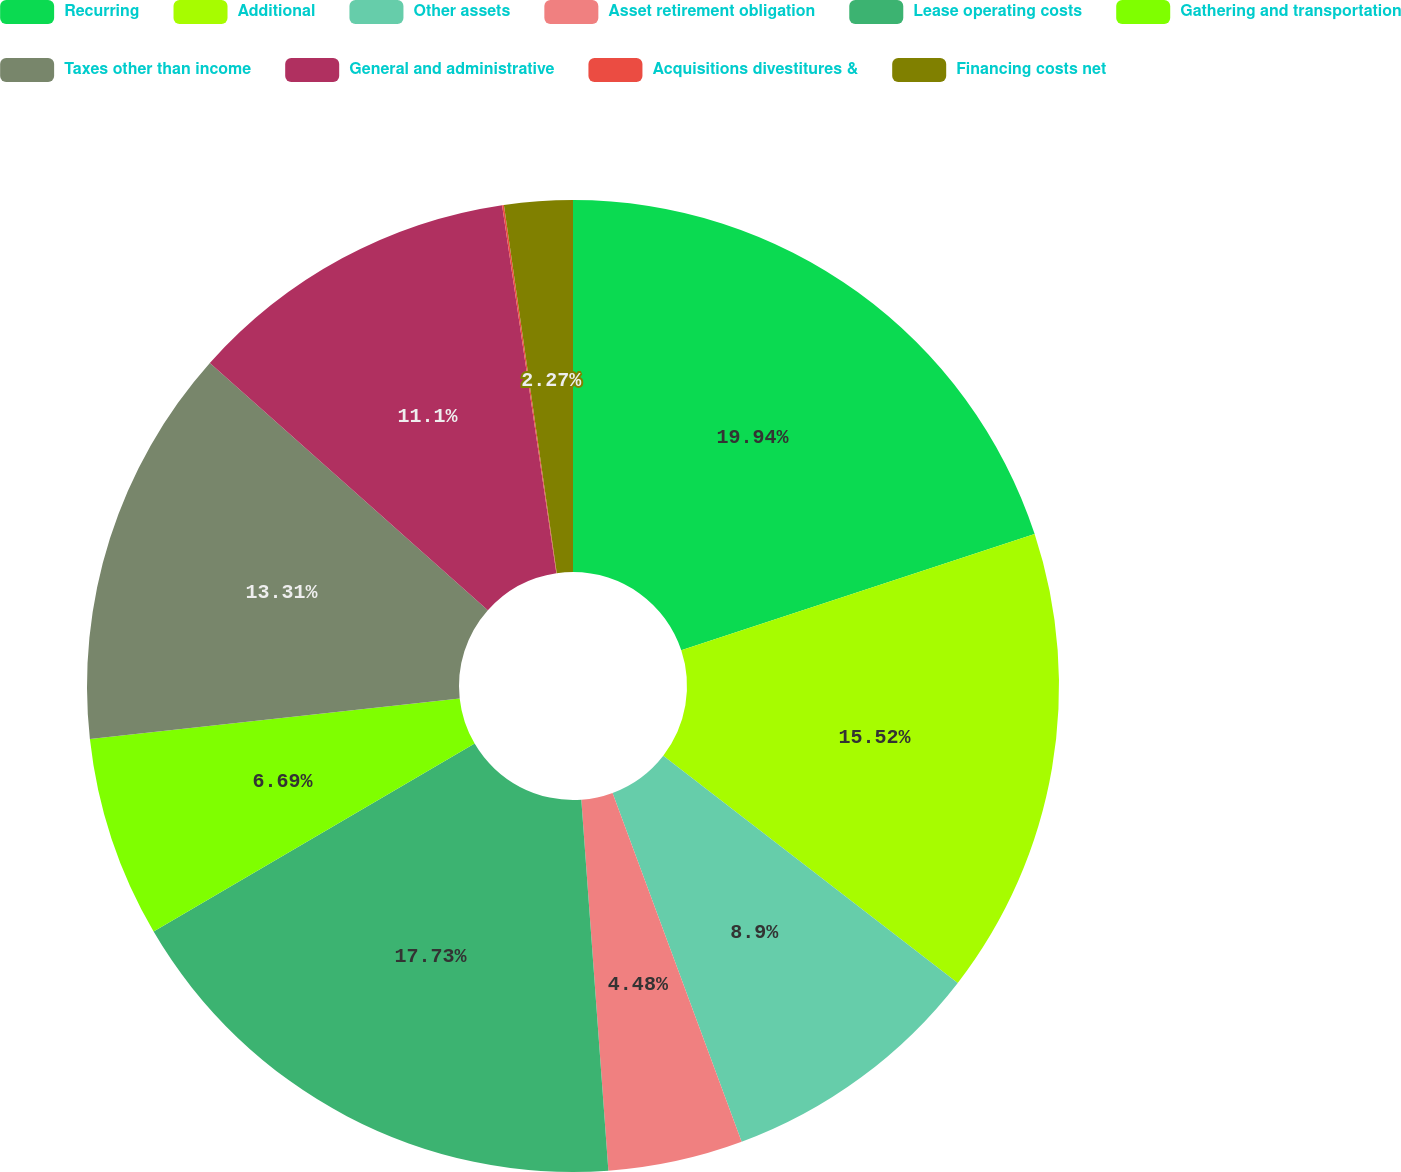<chart> <loc_0><loc_0><loc_500><loc_500><pie_chart><fcel>Recurring<fcel>Additional<fcel>Other assets<fcel>Asset retirement obligation<fcel>Lease operating costs<fcel>Gathering and transportation<fcel>Taxes other than income<fcel>General and administrative<fcel>Acquisitions divestitures &<fcel>Financing costs net<nl><fcel>19.94%<fcel>15.52%<fcel>8.9%<fcel>4.48%<fcel>17.73%<fcel>6.69%<fcel>13.31%<fcel>11.1%<fcel>0.06%<fcel>2.27%<nl></chart> 